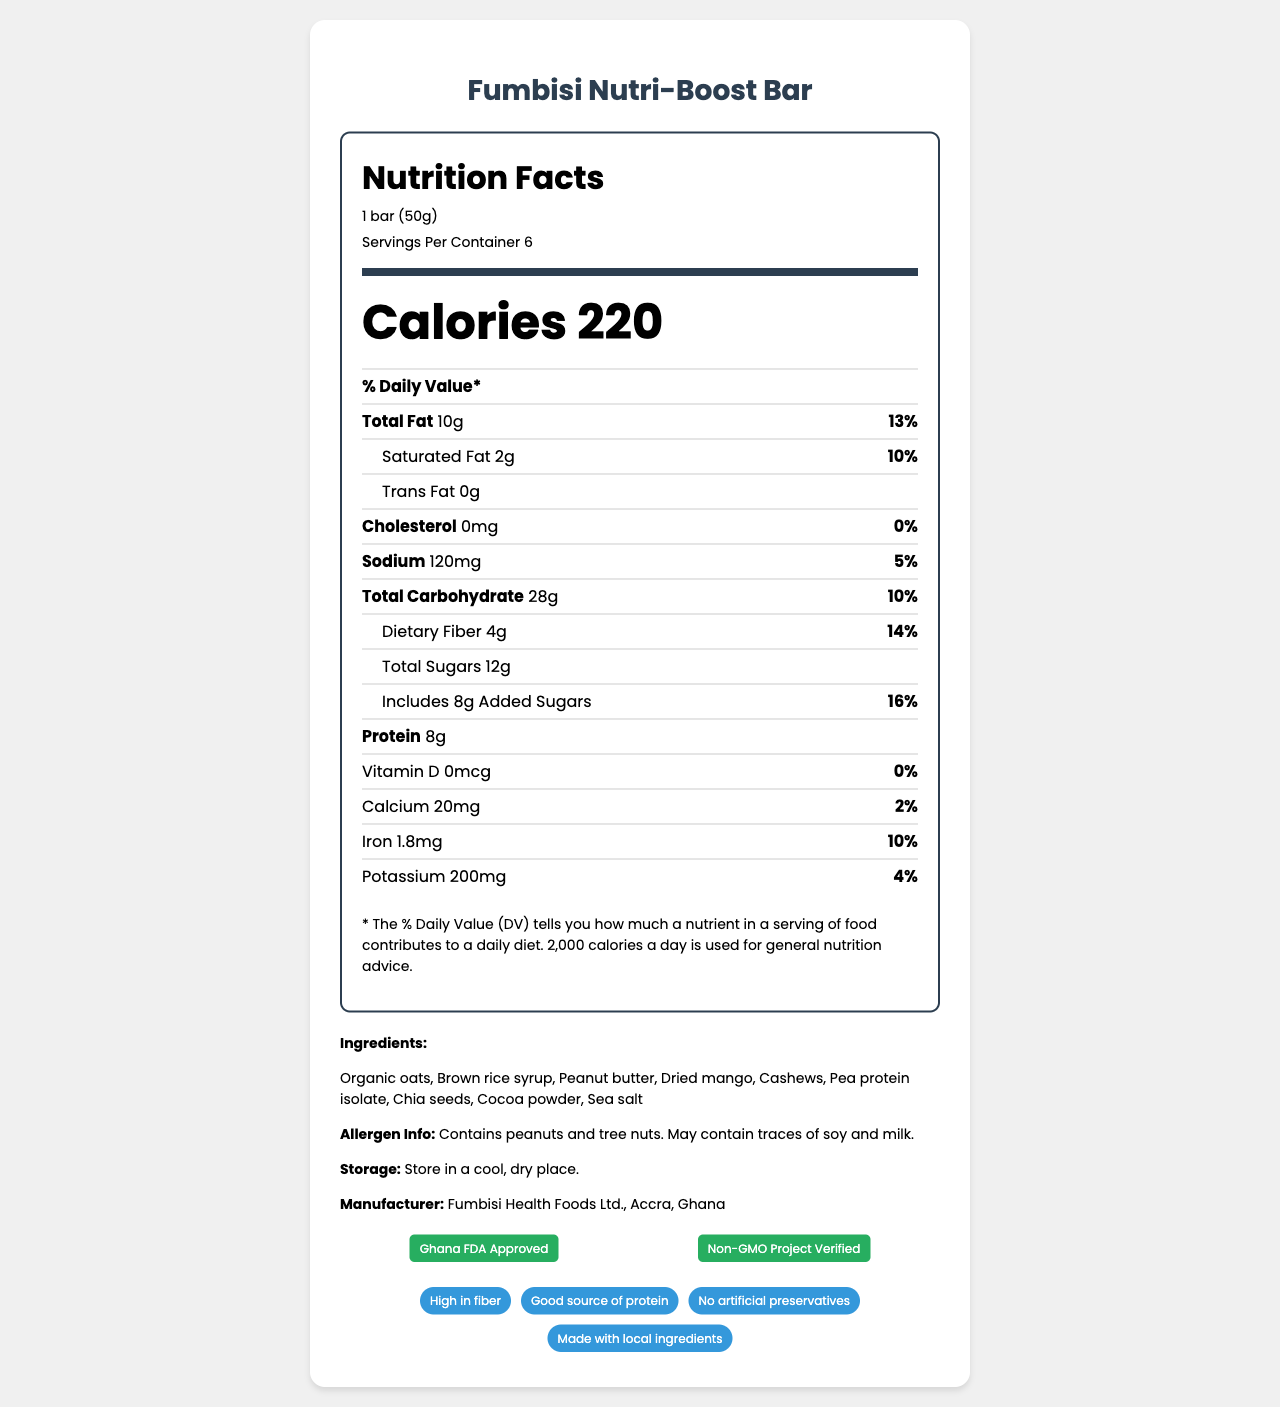What is the serving size for the Fumbisi Nutri-Boost Bar? The serving size is clearly listed at the top of the nutrition label as "1 bar (50g)".
Answer: 1 bar (50g) How many servings are in each container? The document states "Servings Per Container: 6" in the nutrition label section.
Answer: 6 How much protein does one bar contain? The amount of protein is listed as "8g" in the nutrient information.
Answer: 8g What percentage of the daily value of dietary fiber is provided per serving? The daily value percentage for dietary fiber is listed as "14%" next to the amount of dietary fiber (4g).
Answer: 14% Which ingredient in the Fumbisi Nutri-Boost Bar is a potential allergen? The allergen information specifies that the product contains peanuts and tree nuts.
Answer: Peanuts and tree nuts How many calories are in one serving of the Fumbisi Nutri-Boost Bar? The number of calories per serving is prominently displayed as "Calories 220".
Answer: 220 What is the daily value percentage of sodium per serving? The document indicates that the daily value percentage for sodium is "5%".
Answer: 5% How much saturated fat is in each serving? The amount of saturated fat per serving is listed as "2g".
Answer: 2g Which vitamin/mineral is NOT present in the Fumbisi Nutri-Boost Bar? A. Vitamin D B. Calcium C. Iron D. Potassium The document shows "Vitamin D 0mcg" and "0% daily value", indicating that Vitamin D is not present.
Answer: A. Vitamin D What is the main protein ingredient used in the Fumbisi Nutri-Boost Bar? A. Brown rice syrup B. Pea protein isolate C. Cashews D. Chia seeds The ingredient list includes "Pea protein isolate", which is recognized as a primary protein source.
Answer: B. Pea protein isolate Is this product suitable for someone allergic to soy? The allergen info states the product "May contain traces of soy".
Answer: No Summarize the main idea of the document. The document includes a nutrition label for the Fumbisi Nutri-Boost Bar, showing calorie content, macronutrients, vitamins, and minerals. Ingredients are listed, with allergen warnings, and the product is described as high in fiber and protein. Certifications and storage instructions are also given.
Answer: The document provides detailed nutrition facts for the Fumbisi Nutri-Boost Bar, highlighting its health benefits, ingredients, allergen information, and certifications. It targets young entrepreneurs in Accra seeking a nutritious, convenient snack. What local benefits does the Fumbisi Nutri-Boost Bar offer? The document states that the bar "Supports local farmers and businesses" as one of its unique selling points.
Answer: Supports local farmers and businesses How much added sugar is in one serving? The document specifies that there are "8g" of added sugars per serving.
Answer: 8g What certifications does the Fumbisi Nutri-Boost Bar hold? The certifications highlighted in the document are "Ghana FDA Approved" and "Non-GMO Project Verified".
Answer: Ghana FDA Approved and Non-GMO Project Verified Who is the target audience for this product? The document explicitly mentions that the target audience is "Young entrepreneurs in Accra".
Answer: Young entrepreneurs in Accra Does the product contain any artificial preservatives? One of the claims listed in the document is "No artificial preservatives".
Answer: No How many grams of total carbohydrates are in one serving? The nutrient information shows "Total Carbohydrate 28g".
Answer: 28g What is the storage recommendation for the Fumbisi Nutri-Boost Bar? The document instructs to "Store in a cool, dry place".
Answer: Store in a cool, dry place What is the address of the manufacturer? The document mentions "Fumbisi Health Foods Ltd., Accra, Ghana" but does not provide a specific address.
Answer: Cannot be determined 